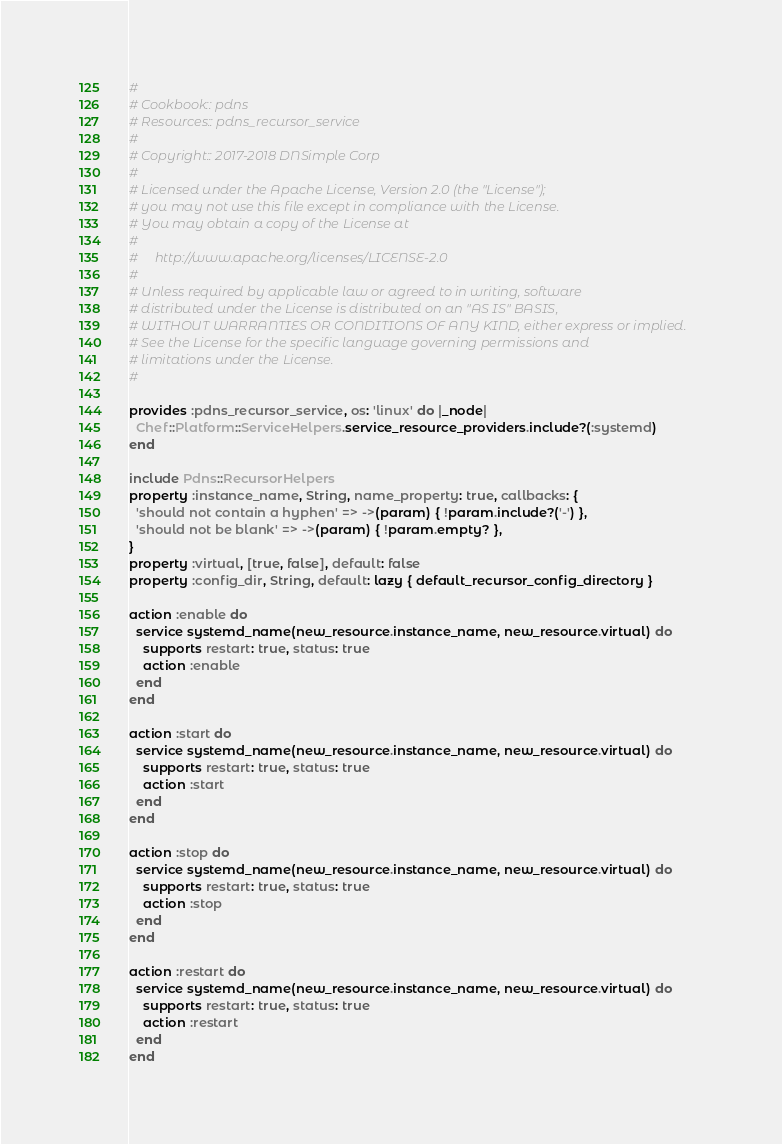Convert code to text. <code><loc_0><loc_0><loc_500><loc_500><_Ruby_>#
# Cookbook:: pdns
# Resources:: pdns_recursor_service
#
# Copyright:: 2017-2018 DNSimple Corp
#
# Licensed under the Apache License, Version 2.0 (the "License");
# you may not use this file except in compliance with the License.
# You may obtain a copy of the License at
#
#     http://www.apache.org/licenses/LICENSE-2.0
#
# Unless required by applicable law or agreed to in writing, software
# distributed under the License is distributed on an "AS IS" BASIS,
# WITHOUT WARRANTIES OR CONDITIONS OF ANY KIND, either express or implied.
# See the License for the specific language governing permissions and
# limitations under the License.
#

provides :pdns_recursor_service, os: 'linux' do |_node|
  Chef::Platform::ServiceHelpers.service_resource_providers.include?(:systemd)
end

include Pdns::RecursorHelpers
property :instance_name, String, name_property: true, callbacks: {
  'should not contain a hyphen' => ->(param) { !param.include?('-') },
  'should not be blank' => ->(param) { !param.empty? },
}
property :virtual, [true, false], default: false
property :config_dir, String, default: lazy { default_recursor_config_directory }

action :enable do
  service systemd_name(new_resource.instance_name, new_resource.virtual) do
    supports restart: true, status: true
    action :enable
  end
end

action :start do
  service systemd_name(new_resource.instance_name, new_resource.virtual) do
    supports restart: true, status: true
    action :start
  end
end

action :stop do
  service systemd_name(new_resource.instance_name, new_resource.virtual) do
    supports restart: true, status: true
    action :stop
  end
end

action :restart do
  service systemd_name(new_resource.instance_name, new_resource.virtual) do
    supports restart: true, status: true
    action :restart
  end
end
</code> 